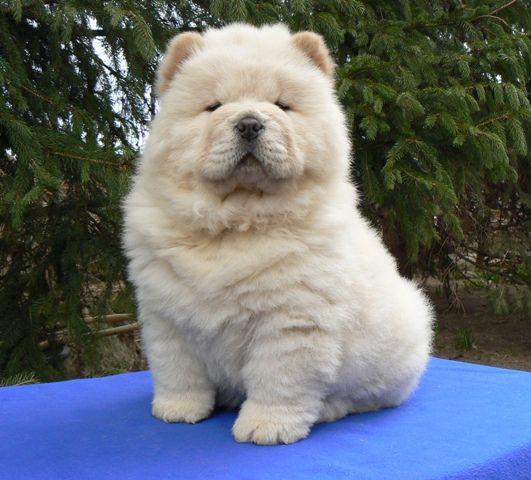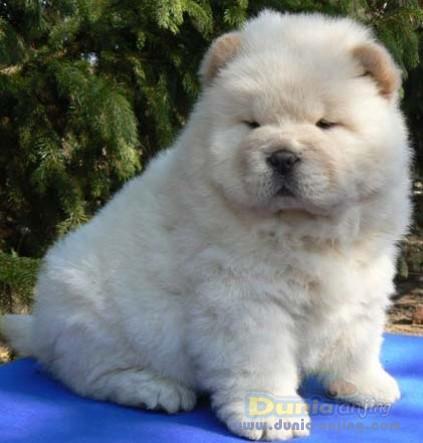The first image is the image on the left, the second image is the image on the right. Considering the images on both sides, is "At least one image shows a cream-colored chow puppy posed on a solid blue, non-textured surface outdoors." valid? Answer yes or no. Yes. The first image is the image on the left, the second image is the image on the right. Assess this claim about the two images: "The dog in the image on the left is outside on a blue mat.". Correct or not? Answer yes or no. Yes. 